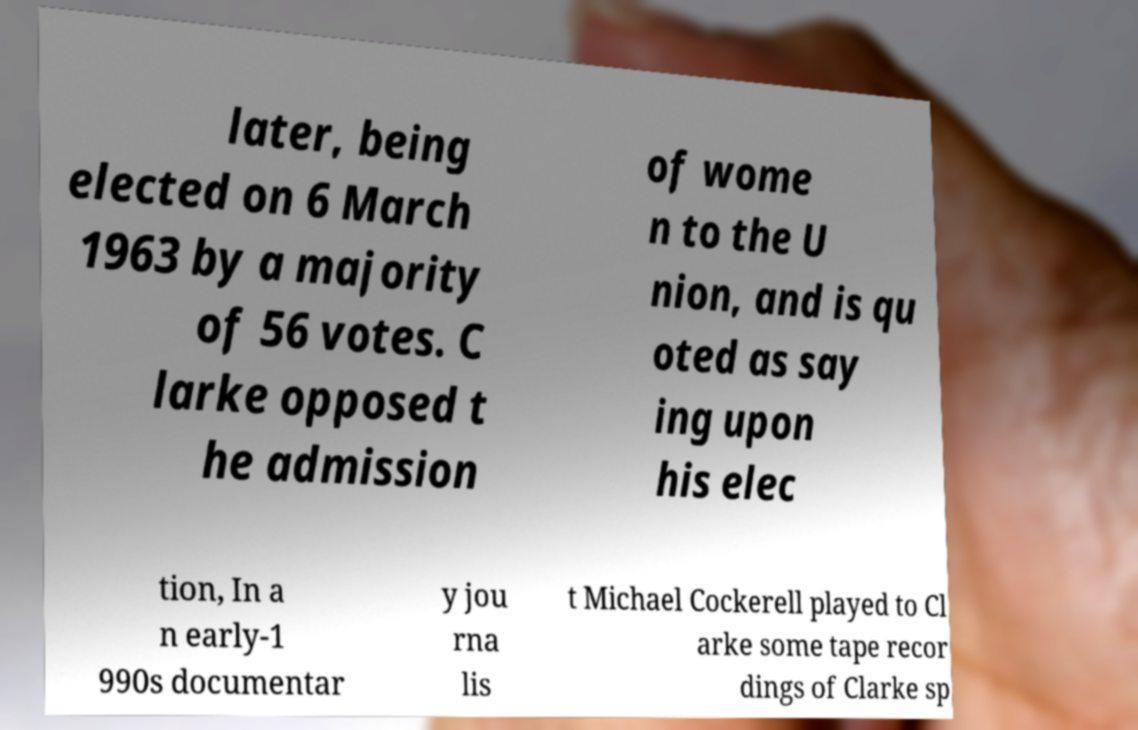Could you assist in decoding the text presented in this image and type it out clearly? later, being elected on 6 March 1963 by a majority of 56 votes. C larke opposed t he admission of wome n to the U nion, and is qu oted as say ing upon his elec tion, In a n early-1 990s documentar y jou rna lis t Michael Cockerell played to Cl arke some tape recor dings of Clarke sp 